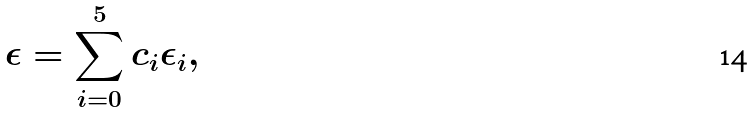Convert formula to latex. <formula><loc_0><loc_0><loc_500><loc_500>\epsilon = \sum _ { i = 0 } ^ { 5 } c _ { i } \epsilon _ { i } ,</formula> 